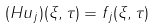<formula> <loc_0><loc_0><loc_500><loc_500>( H u _ { j } ) ( \xi , \tau ) = f _ { j } ( \xi , \tau )</formula> 